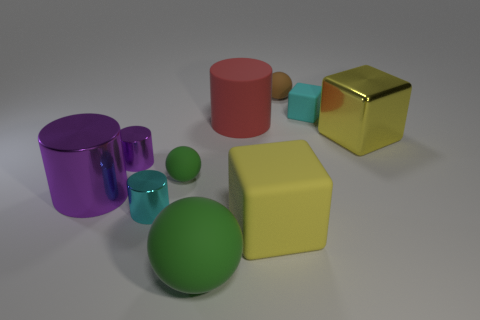Subtract all spheres. How many objects are left? 7 Subtract all big yellow matte cylinders. Subtract all big red cylinders. How many objects are left? 9 Add 2 brown things. How many brown things are left? 3 Add 5 green matte spheres. How many green matte spheres exist? 7 Subtract 0 gray cylinders. How many objects are left? 10 